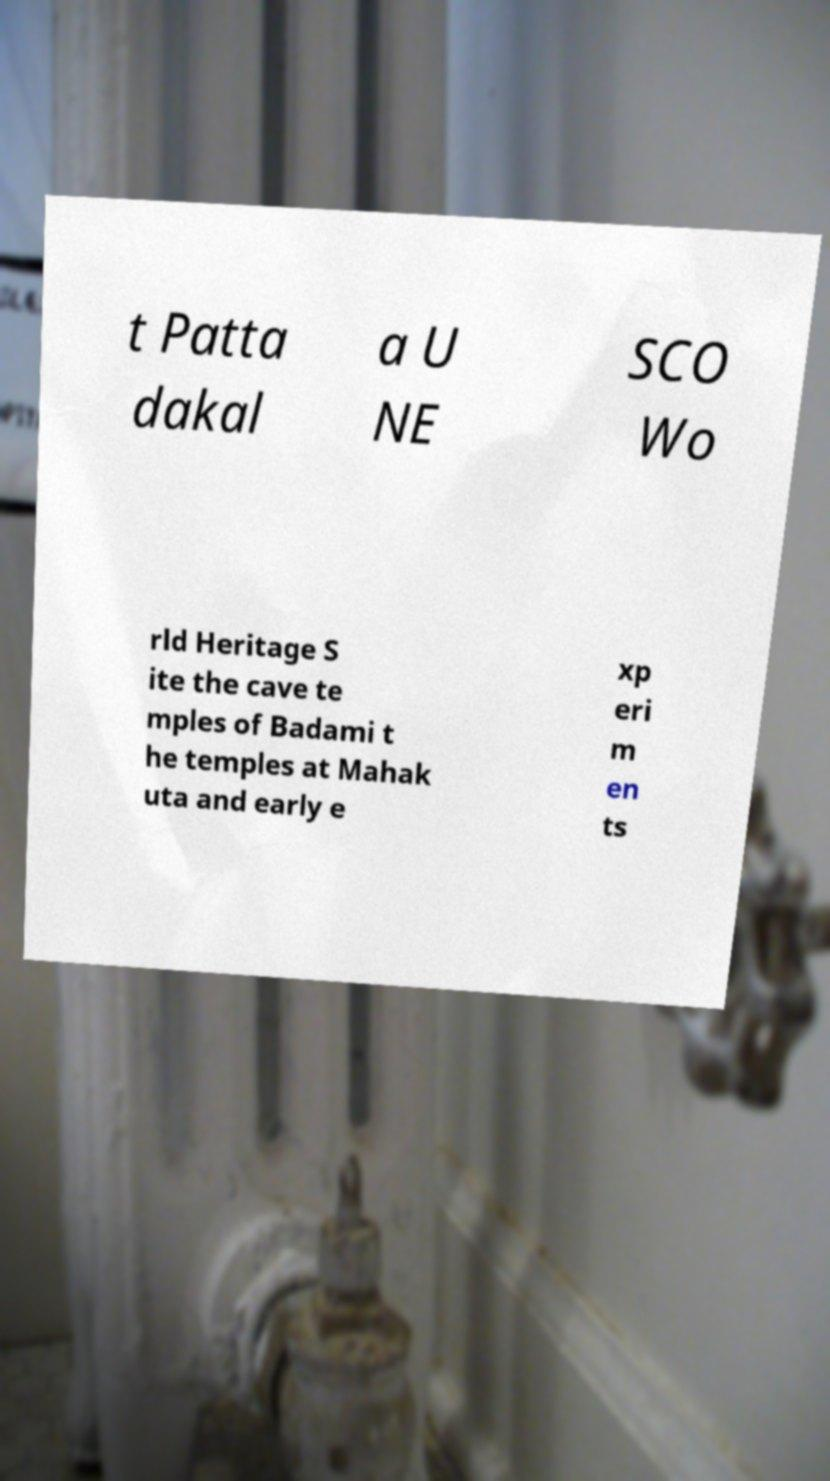There's text embedded in this image that I need extracted. Can you transcribe it verbatim? t Patta dakal a U NE SCO Wo rld Heritage S ite the cave te mples of Badami t he temples at Mahak uta and early e xp eri m en ts 